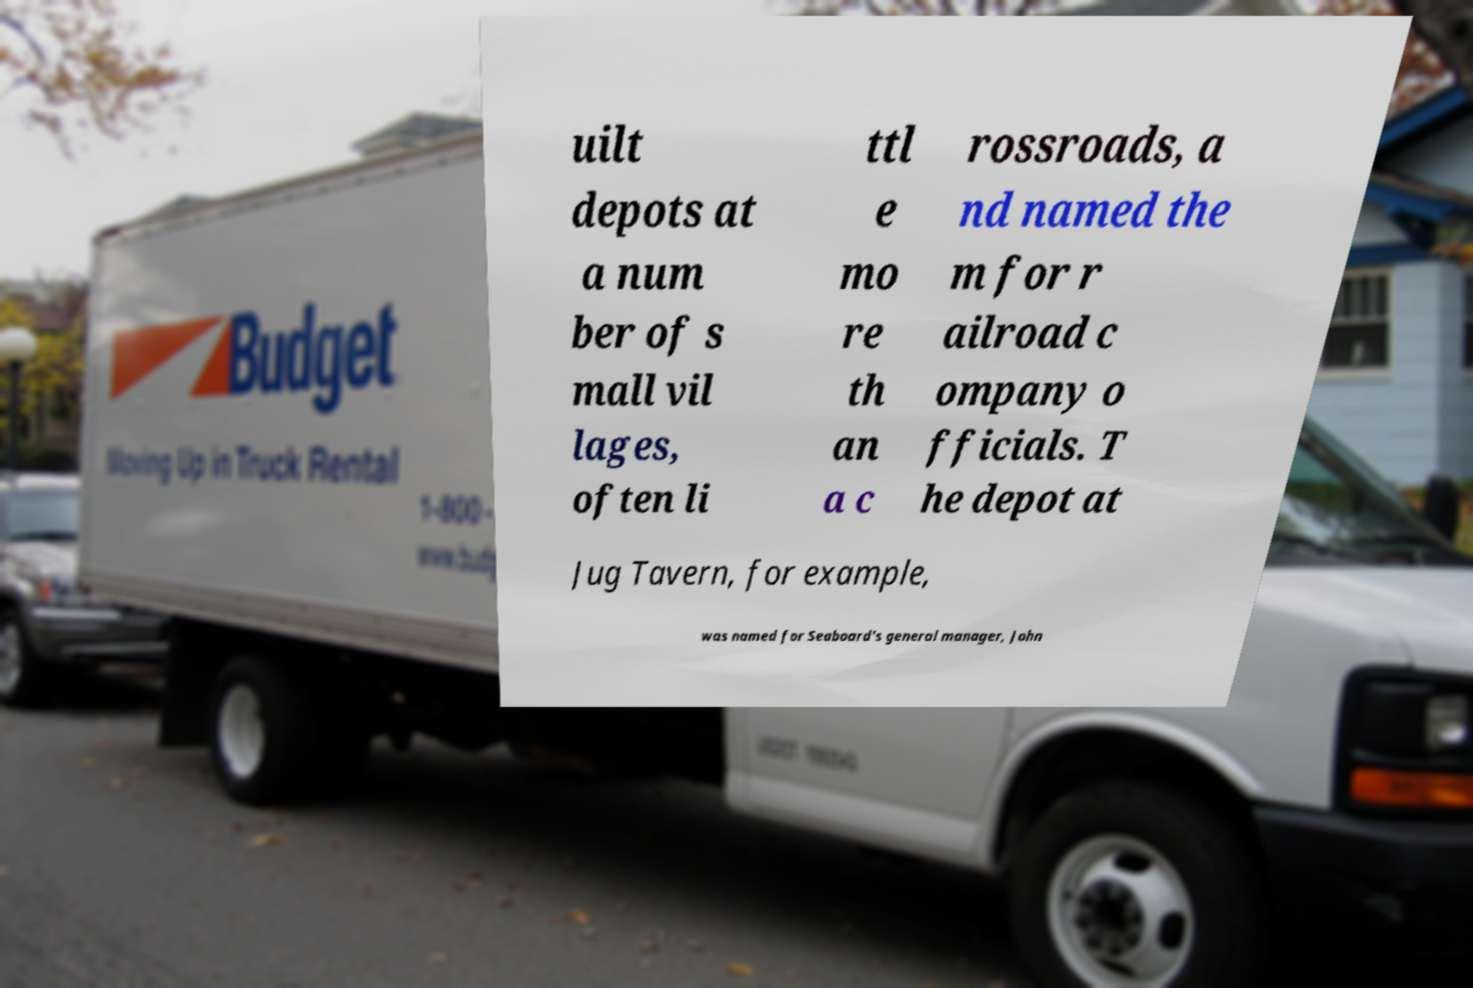What messages or text are displayed in this image? I need them in a readable, typed format. uilt depots at a num ber of s mall vil lages, often li ttl e mo re th an a c rossroads, a nd named the m for r ailroad c ompany o fficials. T he depot at Jug Tavern, for example, was named for Seaboard's general manager, John 